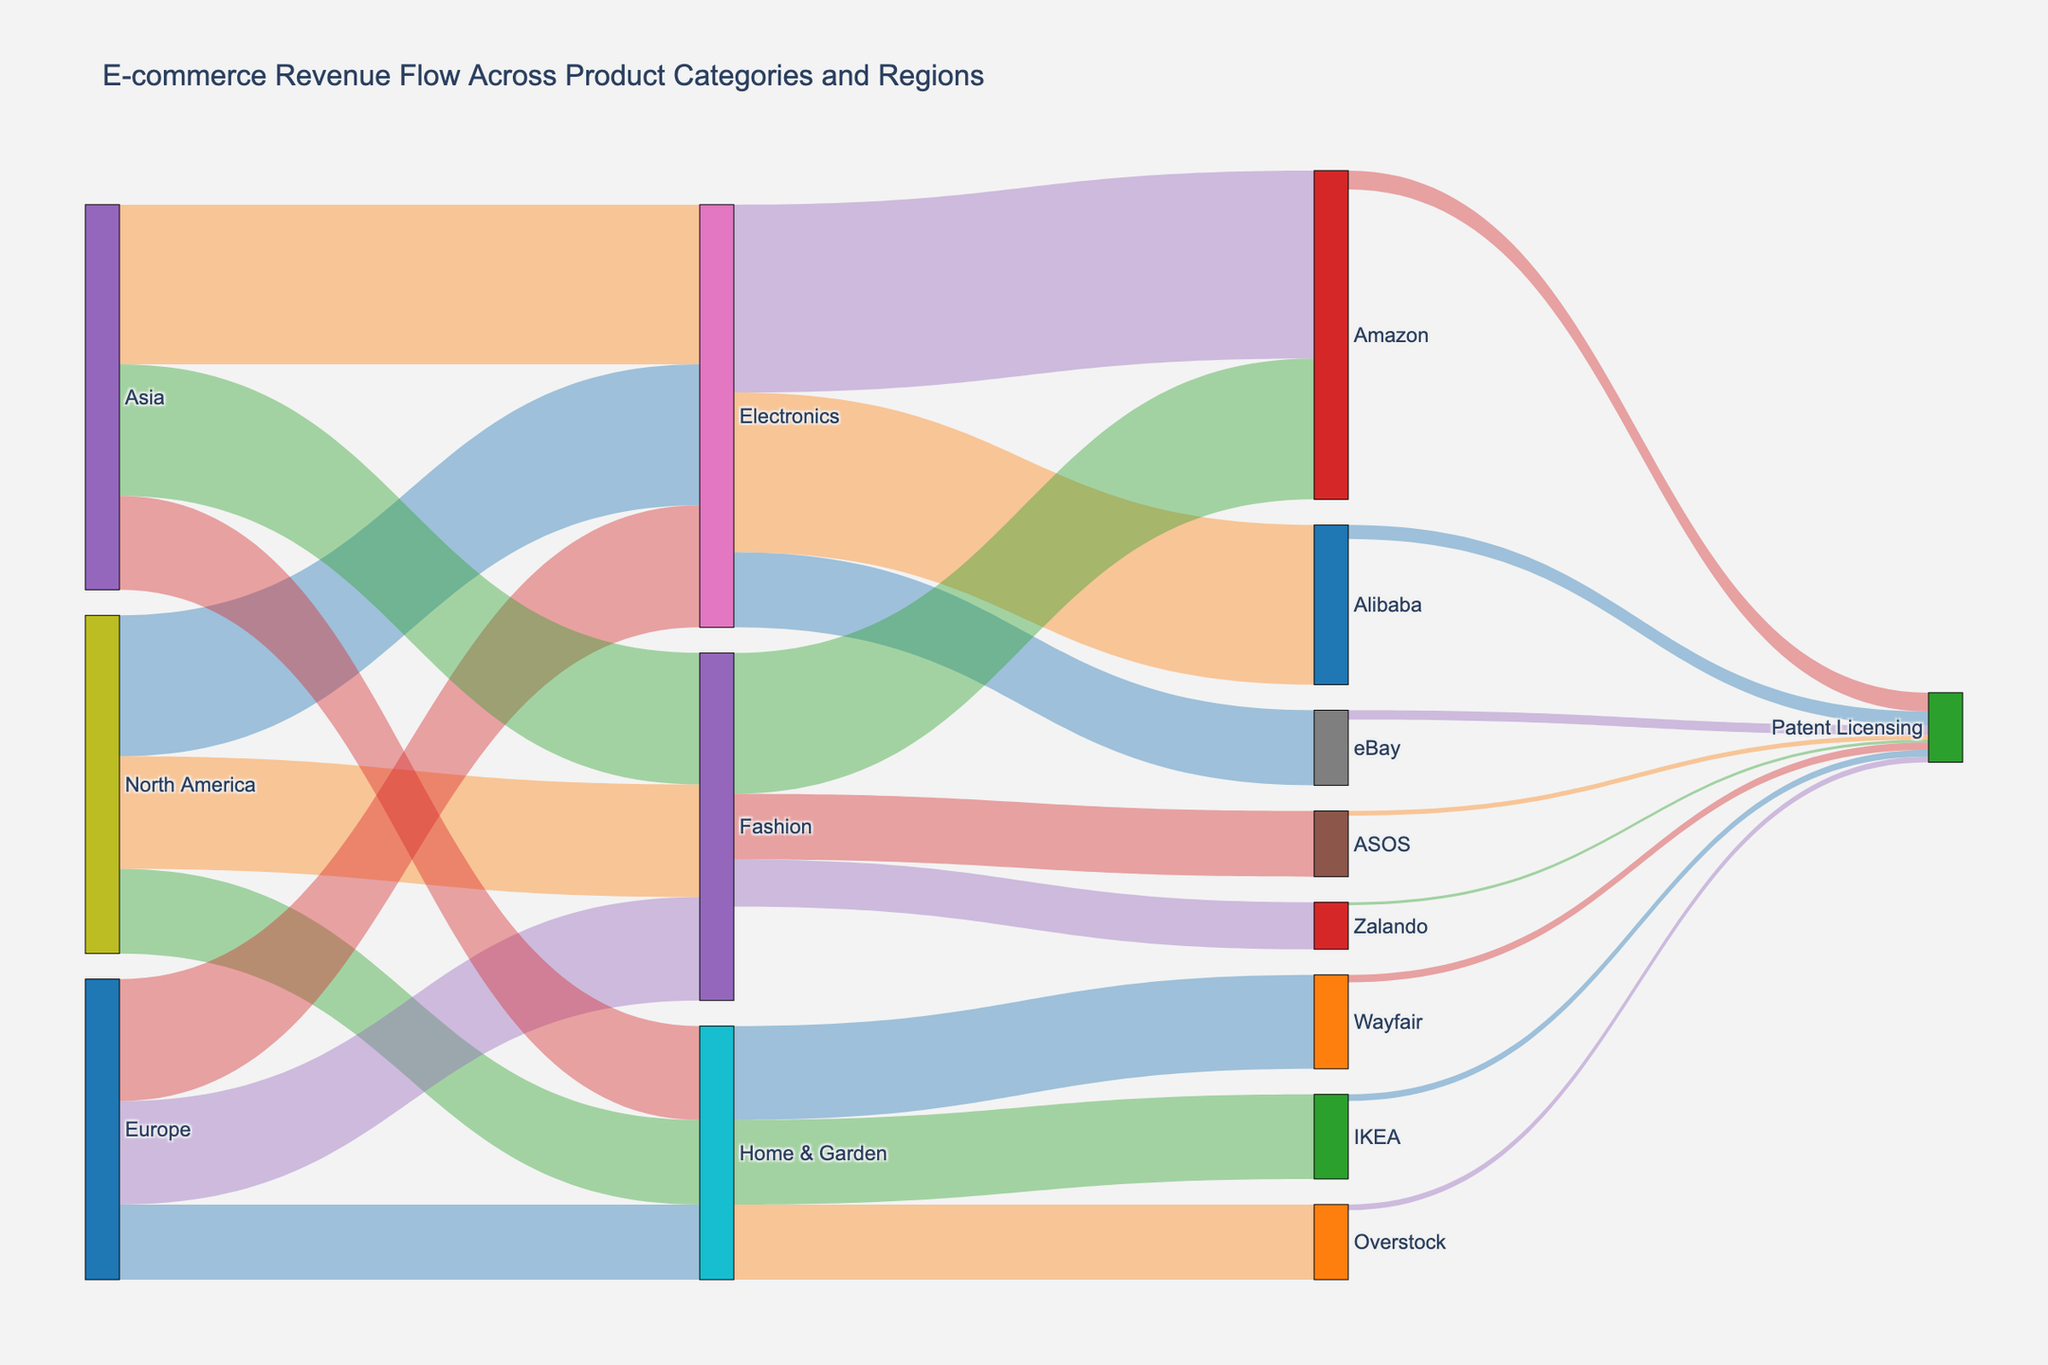Which geographical region generates the highest revenue in Electronics? Look for the region with the largest flow connecting to "Electronics". Asia has the highest value of 1700.
Answer: Asia How much total revenue does Amazon make from all product categories combined? Sum the contributions from each product category to Amazon. Electronics (2000) + Fashion (1500) = 3500.
Answer: 3500 Which product category contributes the least revenue in Europe? Compare the values of European revenue flows to "Electronics", "Fashion", and "Home & Garden". Home & Garden has the lowest with 800.
Answer: Home & Garden What is the total revenue generated by North America across all product categories? Sum the values of all North America's flows. Electronics (1500) + Fashion (1200) + Home & Garden (900) = 3600.
Answer: 3600 Between eBay and Alibaba, which platform has higher electronics revenue? Compare the values for "eBay" and "Alibaba" under "Electronics". eBay has 800, while Alibaba has 1700. Alibaba is higher.
Answer: Alibaba How many e-commerce platforms does Fashion flow to? Count the distinct targets from the "Fashion" source. Fashion flows into Amazon, ASOS, and Zalando, so there are three platforms.
Answer: 3 Which product category generates the most total revenue across all regions? Sum the flows for each product category across all regions. Electronics (1500+1300+1700 = 4500), Fashion (1200+1100+1400 = 3700), Home & Garden (900+800+1000 = 2700). Electronics has the most with 4500.
Answer: Electronics What is the total revenue that goes into Patent Licensing from all e-commerce platforms combined? Sum the contributions from each platform to "Patent Licensing". Amazon (200) + eBay (100) + Alibaba (150) + ASOS (50) + Zalando (30) + Wayfair (80) + Overstock (60) + IKEA (70) = 740.
Answer: 740 Which e-commerce platform receives the least revenue from Home & Garden? Compare the flows from "Home & Garden" to each e-commerce platform: Wayfair (1000), Overstock (800), IKEA (900). Overstock has the least with 800.
Answer: Overstock 